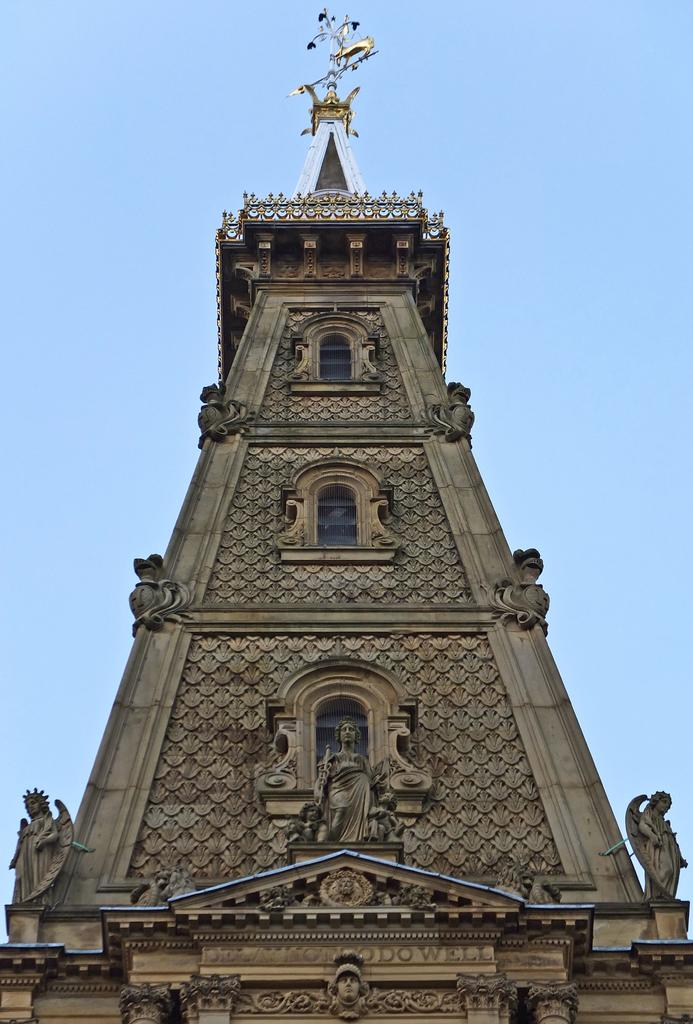What is the main subject in the middle of the image? There is a tower in the middle of the image. What can be seen in the background of the image? The sky is visible in the background of the image. How many slices of pie are present in the image? There is no pie present in the image; it only features a tower and the sky in the background. 